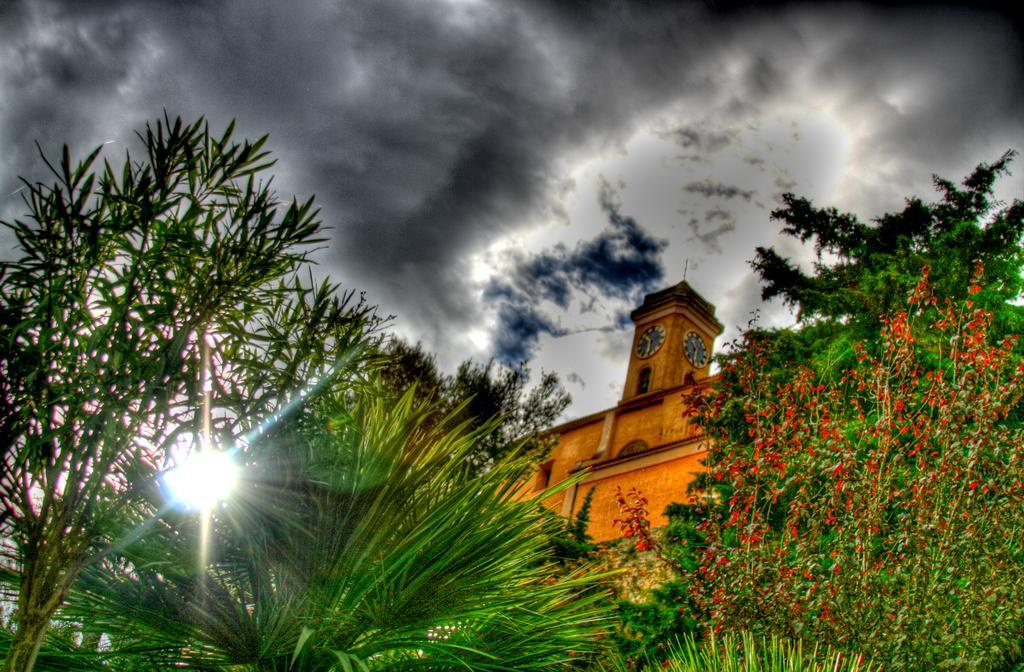In one or two sentences, can you explain what this image depicts? In This image at the bottom there are some trees, and in the center there is one building. At the top of the image there is sky. 